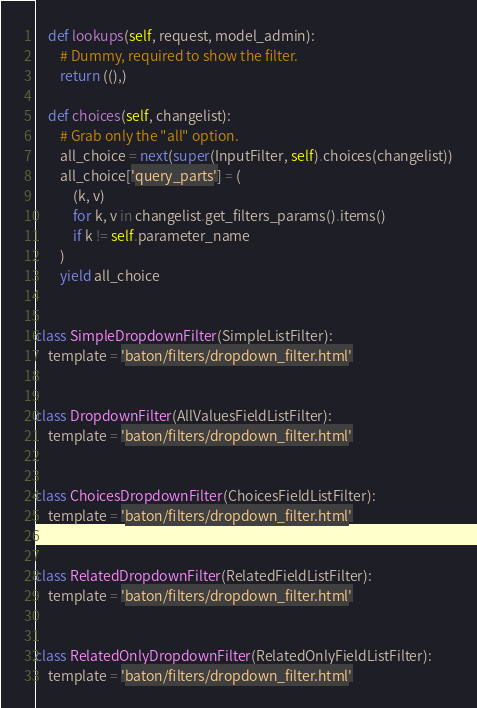<code> <loc_0><loc_0><loc_500><loc_500><_Python_>    def lookups(self, request, model_admin):
        # Dummy, required to show the filter.
        return ((),)

    def choices(self, changelist):
        # Grab only the "all" option.
        all_choice = next(super(InputFilter, self).choices(changelist))
        all_choice['query_parts'] = (
            (k, v)
            for k, v in changelist.get_filters_params().items()
            if k != self.parameter_name
        )
        yield all_choice


class SimpleDropdownFilter(SimpleListFilter):
    template = 'baton/filters/dropdown_filter.html'


class DropdownFilter(AllValuesFieldListFilter):
    template = 'baton/filters/dropdown_filter.html'


class ChoicesDropdownFilter(ChoicesFieldListFilter):
    template = 'baton/filters/dropdown_filter.html'


class RelatedDropdownFilter(RelatedFieldListFilter):
    template = 'baton/filters/dropdown_filter.html'


class RelatedOnlyDropdownFilter(RelatedOnlyFieldListFilter):
    template = 'baton/filters/dropdown_filter.html'
</code> 